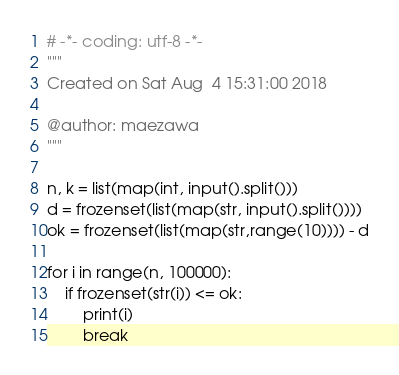<code> <loc_0><loc_0><loc_500><loc_500><_Python_># -*- coding: utf-8 -*-
"""
Created on Sat Aug  4 15:31:00 2018

@author: maezawa
"""

n, k = list(map(int, input().split()))
d = frozenset(list(map(str, input().split())))
ok = frozenset(list(map(str,range(10)))) - d

for i in range(n, 100000):
    if frozenset(str(i)) <= ok:
        print(i)
        break

</code> 